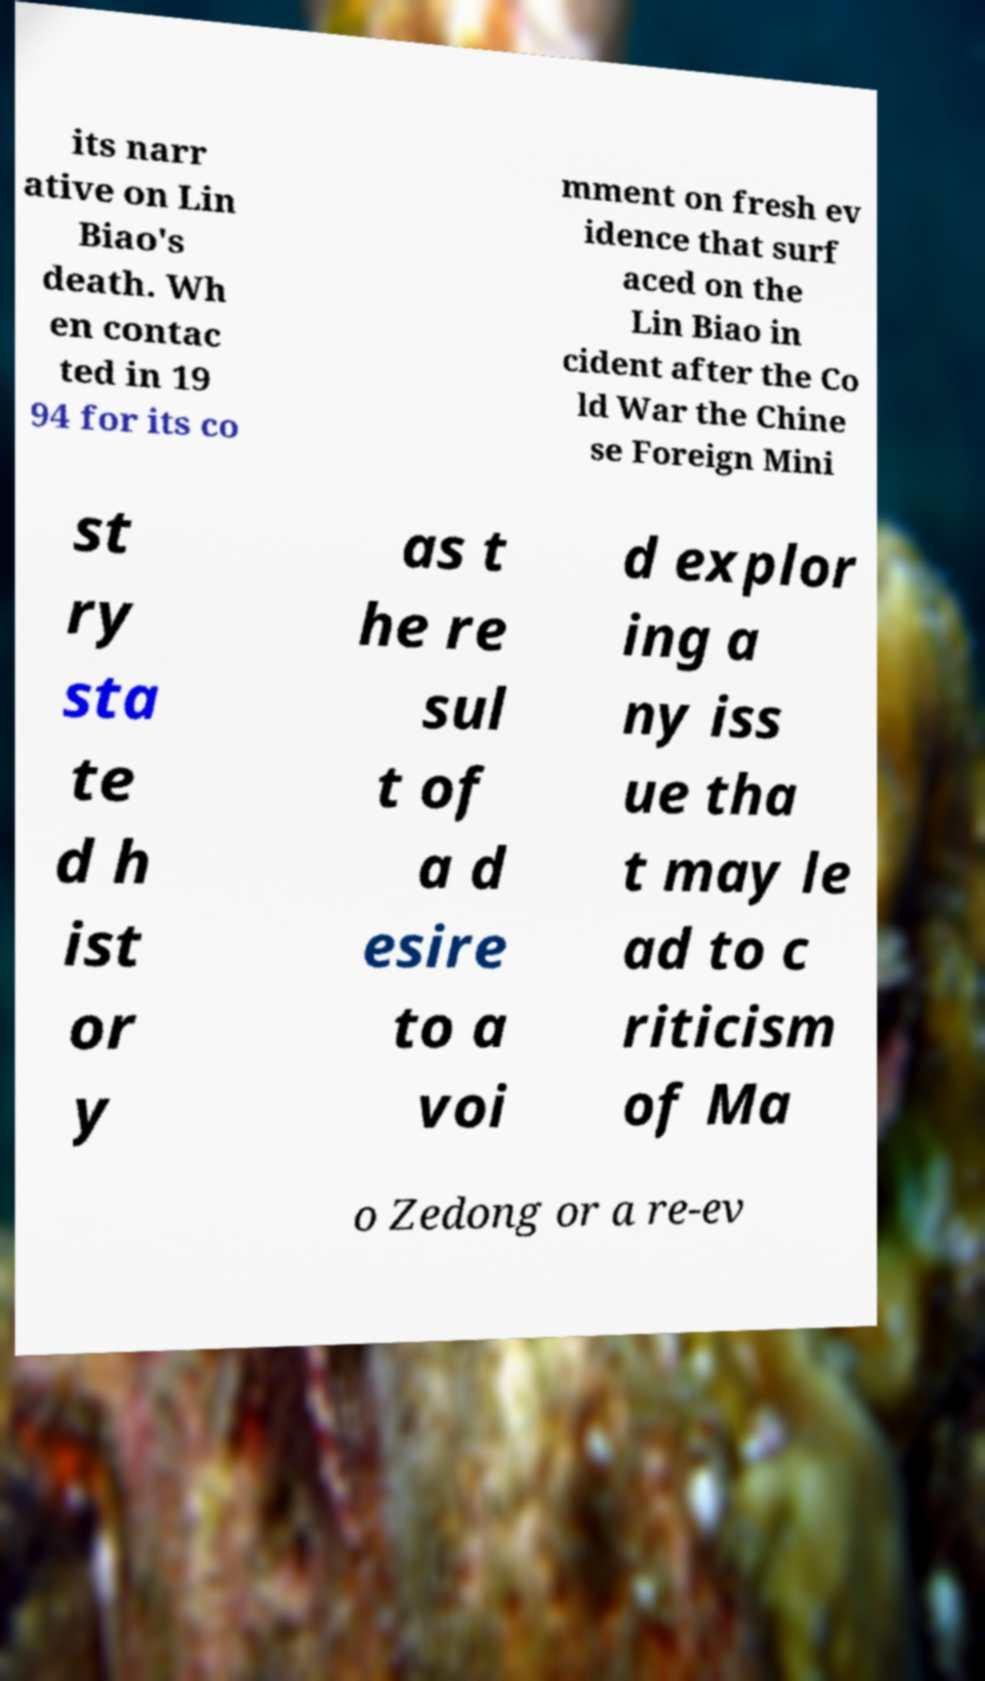Could you assist in decoding the text presented in this image and type it out clearly? its narr ative on Lin Biao's death. Wh en contac ted in 19 94 for its co mment on fresh ev idence that surf aced on the Lin Biao in cident after the Co ld War the Chine se Foreign Mini st ry sta te d h ist or y as t he re sul t of a d esire to a voi d explor ing a ny iss ue tha t may le ad to c riticism of Ma o Zedong or a re-ev 